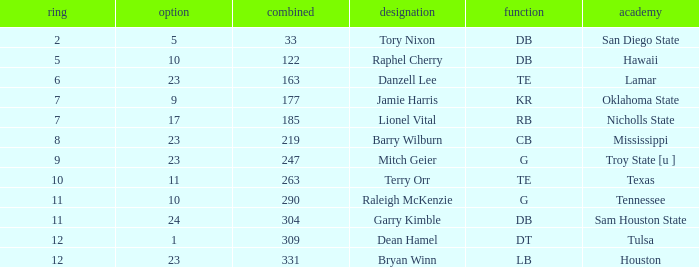How many Picks have an Overall smaller than 304, and a Position of g, and a Round smaller than 11? 1.0. 